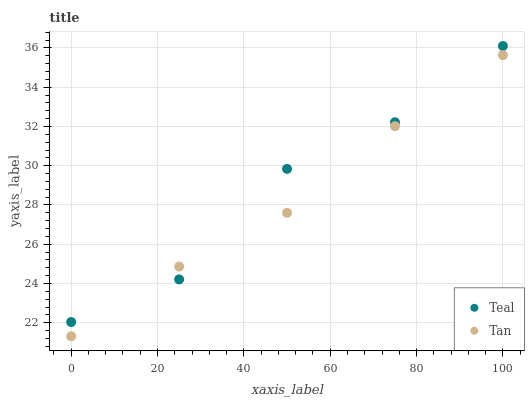Does Tan have the minimum area under the curve?
Answer yes or no. Yes. Does Teal have the maximum area under the curve?
Answer yes or no. Yes. Does Teal have the minimum area under the curve?
Answer yes or no. No. Is Tan the smoothest?
Answer yes or no. Yes. Is Teal the roughest?
Answer yes or no. Yes. Is Teal the smoothest?
Answer yes or no. No. Does Tan have the lowest value?
Answer yes or no. Yes. Does Teal have the lowest value?
Answer yes or no. No. Does Teal have the highest value?
Answer yes or no. Yes. Does Tan intersect Teal?
Answer yes or no. Yes. Is Tan less than Teal?
Answer yes or no. No. Is Tan greater than Teal?
Answer yes or no. No. 